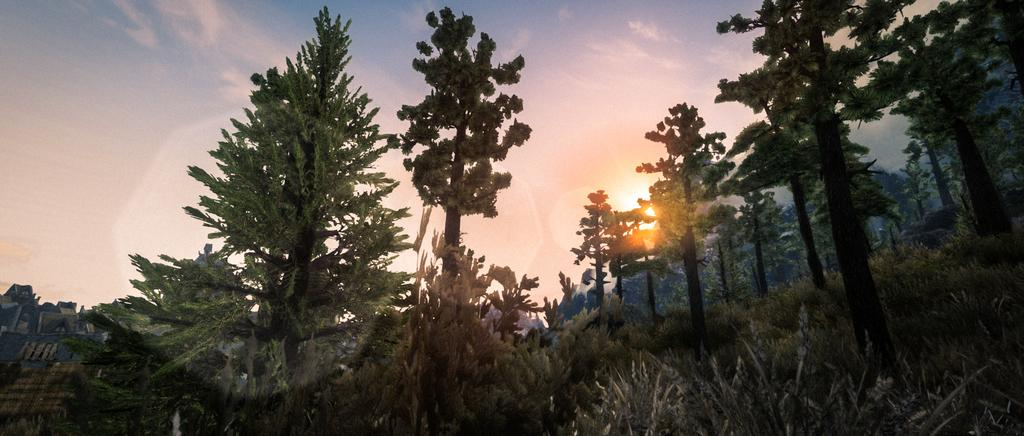What is located in the center of the image? There are trees in the center of the image. What is visible at the top of the image? The sky is visible at the top of the image. Can you describe the sun in the sky? Yes, there is a sun in the sky. What type of rhythm can be heard during the meeting with the cactus in the image? There is no meeting or cactus present in the image, and therefore no rhythm can be heard. 